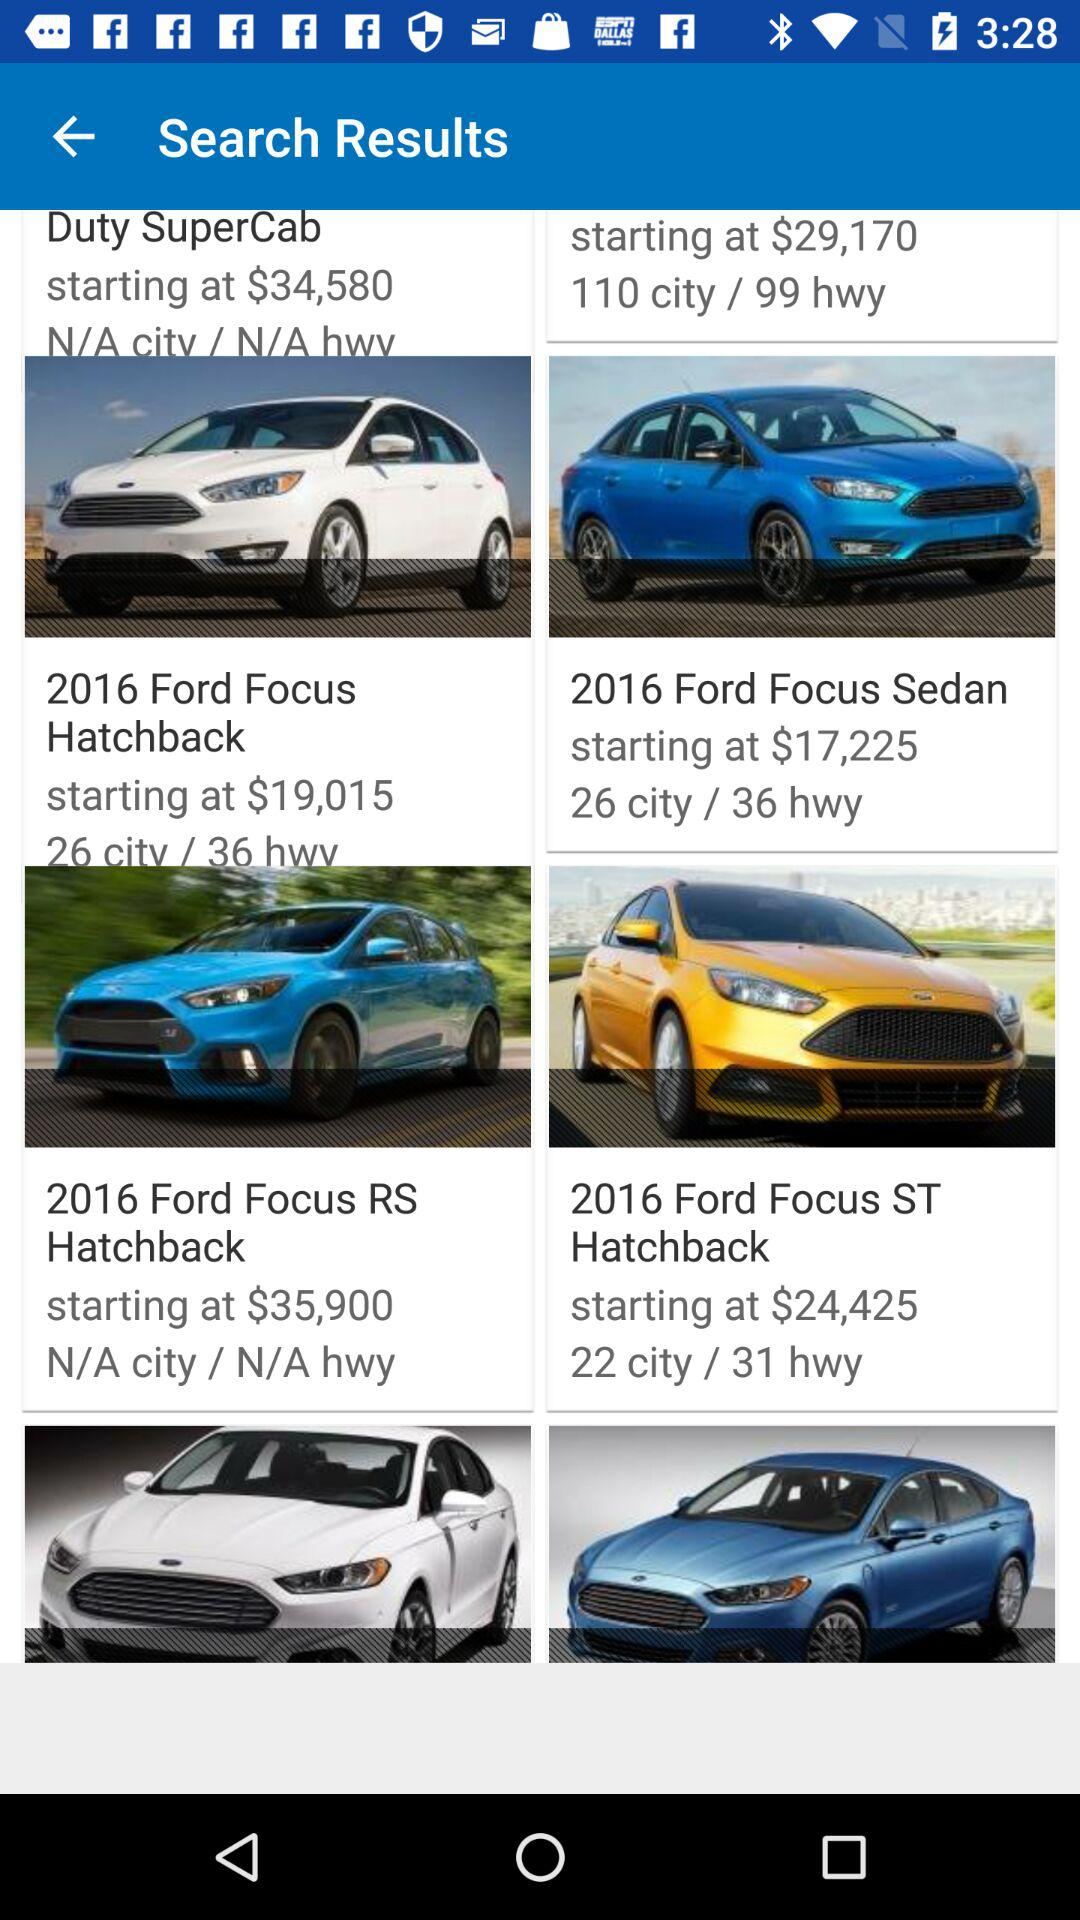How much is the starting cost of the "2016 Ford Focus Sedan"? The starting cost is $17,225. 